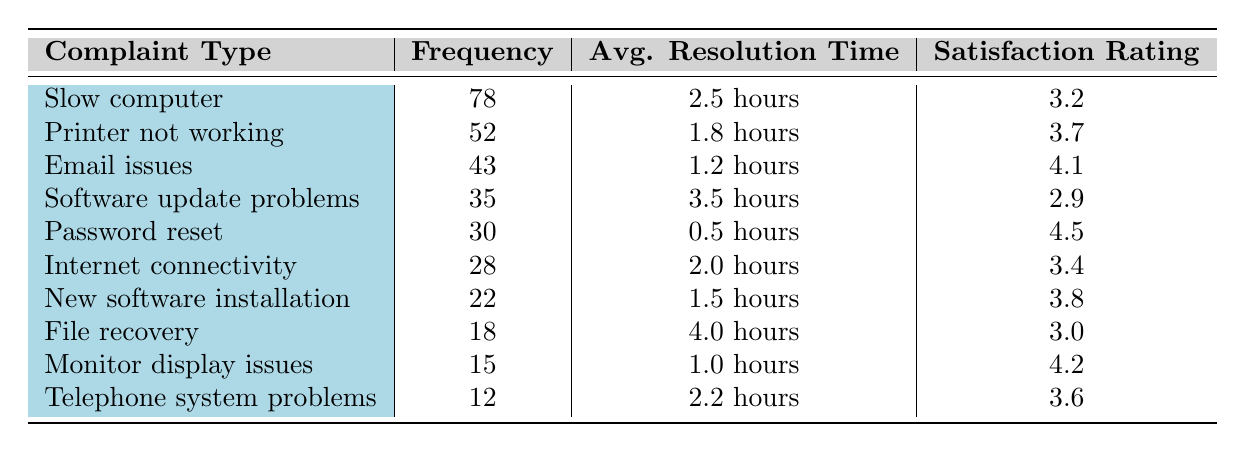What is the complaint type with the highest frequency? By looking at the table, the complaint type listed first is "Slow computer," which has a frequency of 78. This is the highest frequency compared to all other complaint types listed.
Answer: Slow computer What is the average resolution time for printer issues? In the table, the average resolution time for "Printer not working" shows as 1.8 hours. Therefore, this value is taken directly from that row.
Answer: 1.8 hours Which complaint type has the lowest satisfaction rating? The table lists satisfaction ratings for each complaint type, and "Software update problems" has the lowest rating at 2.9, compared to all other listed ratings.
Answer: Software update problems How many complaints were related to internet connectivity? The number of complaints for "Internet connectivity" is stated directly in the table as 28. This is the frequency for that particular complaint type.
Answer: 28 What is the average resolution time for complaints categorized as "slow computer" and "software update problems"? First, identify the average resolution times: "Slow computer" is 2.5 hours and "Software update problems" is 3.5 hours. Next, calculate the average: (2.5 + 3.5) / 2 = 3.0 hours.
Answer: 3.0 hours Is the satisfaction rating for "Password reset" higher than 4.0? Checking the satisfaction rating given for "Password reset," which is 4.5, it is indeed higher than 4.0. Therefore, the answer is yes.
Answer: Yes What is the total frequency of complaints related to email issues and password resets? The frequency for "Email issues" is 43 and for "Password reset," it is 30. Adding these together gives: 43 + 30 = 73.
Answer: 73 How does the average resolution time for "File recovery" compare to that of "Email issues"? "File recovery" has an average resolution time of 4.0 hours while "Email issues" has 1.2 hours. When comparing these, 4.0 hours is greater than 1.2 hours.
Answer: Greater What is the satisfaction rating for the second most frequent complaint type? The second most frequent complaint type is "Printer not working," with a frequency of 52. The corresponding satisfaction rating from the table is 3.7.
Answer: 3.7 What percentage of complaints were about "Monitor display issues"? The frequency of "Monitor display issues" is 15. First, calculate the total frequency of all complaints: 78 + 52 + 43 + 35 + 30 + 28 + 22 + 18 + 15 + 12 =  343. Now, calculate the percentage: (15 / 343) * 100 = approximately 4.37%.
Answer: 4.37% 